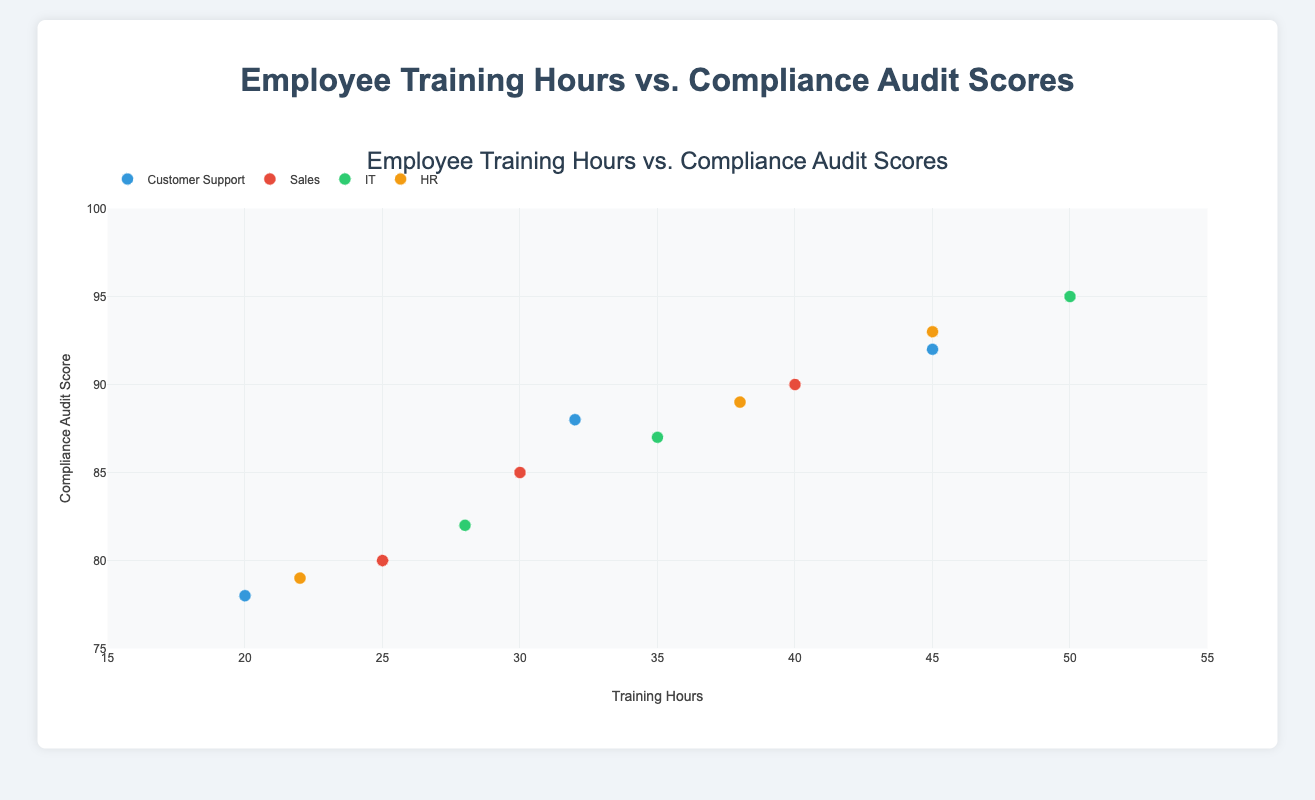How many teams are represented in the plot? The figure shows different groups based on teams. By counting the different groups in the legend, we can determine the number of teams.
Answer: 4 Which team has the highest compliance audit score, and what is that score? By examining the y-axis values, the highest compliance score of 95 belongs to the IT team as shown by the legend's color mapping.
Answer: IT, 95 What is the average training hours of employees in the Sales team? Calculate the average by summing the training hours for all Sales team members (25 + 30 + 40) and dividing by the number of members (3).
Answer: 31.67 Which team has the most data points plotted? Count the number of points for each team by checking the different colored markers representing each team.
Answer: HR Is there a trend between training hours and compliance audit scores across all teams? By visually examining the scatter plot, a positive trend is observable where increased training hours tend to correlate with higher compliance audit scores.
Answer: Yes, there is a positive trend Who has the lowest compliance audit score in the Customer Support team, and how many training hours do they have? Observe the points under the Customer Support category and find the lowest y-value, which corresponds to Claire Williams with 78 scores and 20 training hours.
Answer: Claire Williams, 20 For the HR team, what is the difference in training hours between the employee with the highest and the lowest compliance audit scores? For HR, Leo Young has the highest score (93) with 45 hours, and Jack Hall has the lowest (79) with 22 hours. Subtract the two training hours: 45 - 22.
Answer: 23 Which team appears to have the highest overall compliance audit scores? By visually examining the y-axis positioning of the point clusters, IT stands out with the highest overall compliance scores consistently above 80-95.
Answer: IT Do any employees have compliance audit scores below 80? If so, name them and their corresponding teams. Check the y-axis for points below 80 and refer to hover info. Claire Williams (Customer Support) with 78 and Jack Hall (HR) with 79 are below 80.
Answer: Claire Williams (Customer Support), Jack Hall (HR) Among the Sales team, who has the highest compliance audit score and how many training hours have they completed? Find the highest compliance audit score point in the Sales team category; it corresponds to Frank Miller who has 40 training hours.
Answer: Frank Miller, 40 